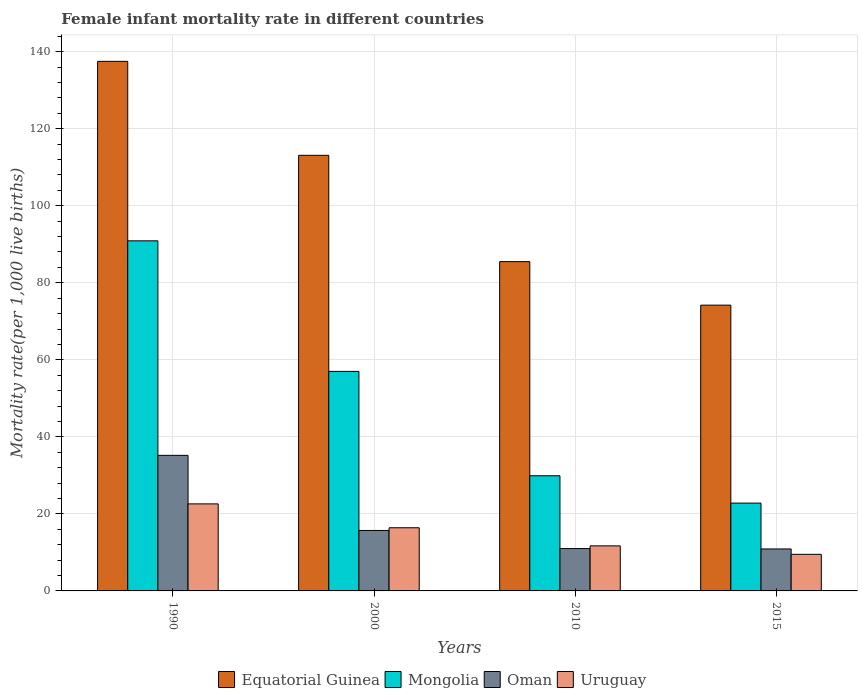Are the number of bars per tick equal to the number of legend labels?
Give a very brief answer. Yes. In how many cases, is the number of bars for a given year not equal to the number of legend labels?
Your answer should be compact. 0. What is the female infant mortality rate in Oman in 1990?
Make the answer very short. 35.2. Across all years, what is the maximum female infant mortality rate in Equatorial Guinea?
Provide a succinct answer. 137.5. Across all years, what is the minimum female infant mortality rate in Oman?
Make the answer very short. 10.9. In which year was the female infant mortality rate in Oman maximum?
Provide a short and direct response. 1990. In which year was the female infant mortality rate in Equatorial Guinea minimum?
Your answer should be compact. 2015. What is the total female infant mortality rate in Oman in the graph?
Ensure brevity in your answer.  72.8. What is the difference between the female infant mortality rate in Equatorial Guinea in 2010 and the female infant mortality rate in Oman in 2015?
Your answer should be very brief. 74.6. What is the average female infant mortality rate in Uruguay per year?
Your answer should be very brief. 15.05. In the year 2010, what is the difference between the female infant mortality rate in Equatorial Guinea and female infant mortality rate in Mongolia?
Your answer should be very brief. 55.6. In how many years, is the female infant mortality rate in Uruguay greater than 32?
Keep it short and to the point. 0. What is the ratio of the female infant mortality rate in Mongolia in 2000 to that in 2010?
Your response must be concise. 1.91. Is the female infant mortality rate in Equatorial Guinea in 2000 less than that in 2010?
Give a very brief answer. No. What is the difference between the highest and the second highest female infant mortality rate in Uruguay?
Offer a terse response. 6.2. What is the difference between the highest and the lowest female infant mortality rate in Uruguay?
Make the answer very short. 13.1. In how many years, is the female infant mortality rate in Equatorial Guinea greater than the average female infant mortality rate in Equatorial Guinea taken over all years?
Offer a very short reply. 2. Is the sum of the female infant mortality rate in Equatorial Guinea in 2000 and 2010 greater than the maximum female infant mortality rate in Uruguay across all years?
Your answer should be very brief. Yes. What does the 1st bar from the left in 1990 represents?
Your response must be concise. Equatorial Guinea. What does the 1st bar from the right in 2015 represents?
Offer a terse response. Uruguay. Is it the case that in every year, the sum of the female infant mortality rate in Oman and female infant mortality rate in Equatorial Guinea is greater than the female infant mortality rate in Uruguay?
Ensure brevity in your answer.  Yes. Are all the bars in the graph horizontal?
Offer a very short reply. No. How many years are there in the graph?
Provide a short and direct response. 4. How are the legend labels stacked?
Your answer should be very brief. Horizontal. What is the title of the graph?
Your response must be concise. Female infant mortality rate in different countries. Does "Virgin Islands" appear as one of the legend labels in the graph?
Provide a succinct answer. No. What is the label or title of the Y-axis?
Offer a very short reply. Mortality rate(per 1,0 live births). What is the Mortality rate(per 1,000 live births) in Equatorial Guinea in 1990?
Your answer should be very brief. 137.5. What is the Mortality rate(per 1,000 live births) of Mongolia in 1990?
Your answer should be very brief. 90.9. What is the Mortality rate(per 1,000 live births) of Oman in 1990?
Your response must be concise. 35.2. What is the Mortality rate(per 1,000 live births) of Uruguay in 1990?
Provide a succinct answer. 22.6. What is the Mortality rate(per 1,000 live births) of Equatorial Guinea in 2000?
Your answer should be compact. 113.1. What is the Mortality rate(per 1,000 live births) in Oman in 2000?
Offer a terse response. 15.7. What is the Mortality rate(per 1,000 live births) of Equatorial Guinea in 2010?
Your answer should be compact. 85.5. What is the Mortality rate(per 1,000 live births) of Mongolia in 2010?
Offer a terse response. 29.9. What is the Mortality rate(per 1,000 live births) in Uruguay in 2010?
Your answer should be very brief. 11.7. What is the Mortality rate(per 1,000 live births) of Equatorial Guinea in 2015?
Your response must be concise. 74.2. What is the Mortality rate(per 1,000 live births) of Mongolia in 2015?
Provide a succinct answer. 22.8. What is the Mortality rate(per 1,000 live births) of Oman in 2015?
Ensure brevity in your answer.  10.9. What is the Mortality rate(per 1,000 live births) in Uruguay in 2015?
Your answer should be compact. 9.5. Across all years, what is the maximum Mortality rate(per 1,000 live births) of Equatorial Guinea?
Offer a very short reply. 137.5. Across all years, what is the maximum Mortality rate(per 1,000 live births) in Mongolia?
Offer a terse response. 90.9. Across all years, what is the maximum Mortality rate(per 1,000 live births) of Oman?
Your answer should be compact. 35.2. Across all years, what is the maximum Mortality rate(per 1,000 live births) of Uruguay?
Provide a short and direct response. 22.6. Across all years, what is the minimum Mortality rate(per 1,000 live births) of Equatorial Guinea?
Provide a short and direct response. 74.2. Across all years, what is the minimum Mortality rate(per 1,000 live births) of Mongolia?
Offer a terse response. 22.8. What is the total Mortality rate(per 1,000 live births) in Equatorial Guinea in the graph?
Keep it short and to the point. 410.3. What is the total Mortality rate(per 1,000 live births) in Mongolia in the graph?
Provide a succinct answer. 200.6. What is the total Mortality rate(per 1,000 live births) of Oman in the graph?
Offer a very short reply. 72.8. What is the total Mortality rate(per 1,000 live births) of Uruguay in the graph?
Ensure brevity in your answer.  60.2. What is the difference between the Mortality rate(per 1,000 live births) of Equatorial Guinea in 1990 and that in 2000?
Provide a succinct answer. 24.4. What is the difference between the Mortality rate(per 1,000 live births) of Mongolia in 1990 and that in 2000?
Give a very brief answer. 33.9. What is the difference between the Mortality rate(per 1,000 live births) in Uruguay in 1990 and that in 2000?
Give a very brief answer. 6.2. What is the difference between the Mortality rate(per 1,000 live births) in Mongolia in 1990 and that in 2010?
Offer a terse response. 61. What is the difference between the Mortality rate(per 1,000 live births) in Oman in 1990 and that in 2010?
Provide a short and direct response. 24.2. What is the difference between the Mortality rate(per 1,000 live births) of Equatorial Guinea in 1990 and that in 2015?
Give a very brief answer. 63.3. What is the difference between the Mortality rate(per 1,000 live births) of Mongolia in 1990 and that in 2015?
Provide a short and direct response. 68.1. What is the difference between the Mortality rate(per 1,000 live births) in Oman in 1990 and that in 2015?
Your response must be concise. 24.3. What is the difference between the Mortality rate(per 1,000 live births) in Uruguay in 1990 and that in 2015?
Your answer should be very brief. 13.1. What is the difference between the Mortality rate(per 1,000 live births) of Equatorial Guinea in 2000 and that in 2010?
Your response must be concise. 27.6. What is the difference between the Mortality rate(per 1,000 live births) of Mongolia in 2000 and that in 2010?
Give a very brief answer. 27.1. What is the difference between the Mortality rate(per 1,000 live births) of Equatorial Guinea in 2000 and that in 2015?
Give a very brief answer. 38.9. What is the difference between the Mortality rate(per 1,000 live births) in Mongolia in 2000 and that in 2015?
Your response must be concise. 34.2. What is the difference between the Mortality rate(per 1,000 live births) of Oman in 2000 and that in 2015?
Keep it short and to the point. 4.8. What is the difference between the Mortality rate(per 1,000 live births) of Equatorial Guinea in 2010 and that in 2015?
Provide a succinct answer. 11.3. What is the difference between the Mortality rate(per 1,000 live births) in Oman in 2010 and that in 2015?
Make the answer very short. 0.1. What is the difference between the Mortality rate(per 1,000 live births) of Equatorial Guinea in 1990 and the Mortality rate(per 1,000 live births) of Mongolia in 2000?
Give a very brief answer. 80.5. What is the difference between the Mortality rate(per 1,000 live births) of Equatorial Guinea in 1990 and the Mortality rate(per 1,000 live births) of Oman in 2000?
Offer a very short reply. 121.8. What is the difference between the Mortality rate(per 1,000 live births) of Equatorial Guinea in 1990 and the Mortality rate(per 1,000 live births) of Uruguay in 2000?
Keep it short and to the point. 121.1. What is the difference between the Mortality rate(per 1,000 live births) in Mongolia in 1990 and the Mortality rate(per 1,000 live births) in Oman in 2000?
Make the answer very short. 75.2. What is the difference between the Mortality rate(per 1,000 live births) in Mongolia in 1990 and the Mortality rate(per 1,000 live births) in Uruguay in 2000?
Provide a succinct answer. 74.5. What is the difference between the Mortality rate(per 1,000 live births) in Equatorial Guinea in 1990 and the Mortality rate(per 1,000 live births) in Mongolia in 2010?
Keep it short and to the point. 107.6. What is the difference between the Mortality rate(per 1,000 live births) of Equatorial Guinea in 1990 and the Mortality rate(per 1,000 live births) of Oman in 2010?
Your response must be concise. 126.5. What is the difference between the Mortality rate(per 1,000 live births) in Equatorial Guinea in 1990 and the Mortality rate(per 1,000 live births) in Uruguay in 2010?
Ensure brevity in your answer.  125.8. What is the difference between the Mortality rate(per 1,000 live births) of Mongolia in 1990 and the Mortality rate(per 1,000 live births) of Oman in 2010?
Keep it short and to the point. 79.9. What is the difference between the Mortality rate(per 1,000 live births) in Mongolia in 1990 and the Mortality rate(per 1,000 live births) in Uruguay in 2010?
Provide a short and direct response. 79.2. What is the difference between the Mortality rate(per 1,000 live births) of Equatorial Guinea in 1990 and the Mortality rate(per 1,000 live births) of Mongolia in 2015?
Provide a succinct answer. 114.7. What is the difference between the Mortality rate(per 1,000 live births) of Equatorial Guinea in 1990 and the Mortality rate(per 1,000 live births) of Oman in 2015?
Offer a terse response. 126.6. What is the difference between the Mortality rate(per 1,000 live births) in Equatorial Guinea in 1990 and the Mortality rate(per 1,000 live births) in Uruguay in 2015?
Your answer should be very brief. 128. What is the difference between the Mortality rate(per 1,000 live births) of Mongolia in 1990 and the Mortality rate(per 1,000 live births) of Uruguay in 2015?
Your answer should be compact. 81.4. What is the difference between the Mortality rate(per 1,000 live births) in Oman in 1990 and the Mortality rate(per 1,000 live births) in Uruguay in 2015?
Your answer should be compact. 25.7. What is the difference between the Mortality rate(per 1,000 live births) in Equatorial Guinea in 2000 and the Mortality rate(per 1,000 live births) in Mongolia in 2010?
Your response must be concise. 83.2. What is the difference between the Mortality rate(per 1,000 live births) in Equatorial Guinea in 2000 and the Mortality rate(per 1,000 live births) in Oman in 2010?
Make the answer very short. 102.1. What is the difference between the Mortality rate(per 1,000 live births) in Equatorial Guinea in 2000 and the Mortality rate(per 1,000 live births) in Uruguay in 2010?
Provide a succinct answer. 101.4. What is the difference between the Mortality rate(per 1,000 live births) in Mongolia in 2000 and the Mortality rate(per 1,000 live births) in Oman in 2010?
Make the answer very short. 46. What is the difference between the Mortality rate(per 1,000 live births) in Mongolia in 2000 and the Mortality rate(per 1,000 live births) in Uruguay in 2010?
Give a very brief answer. 45.3. What is the difference between the Mortality rate(per 1,000 live births) in Oman in 2000 and the Mortality rate(per 1,000 live births) in Uruguay in 2010?
Provide a succinct answer. 4. What is the difference between the Mortality rate(per 1,000 live births) of Equatorial Guinea in 2000 and the Mortality rate(per 1,000 live births) of Mongolia in 2015?
Provide a short and direct response. 90.3. What is the difference between the Mortality rate(per 1,000 live births) of Equatorial Guinea in 2000 and the Mortality rate(per 1,000 live births) of Oman in 2015?
Keep it short and to the point. 102.2. What is the difference between the Mortality rate(per 1,000 live births) in Equatorial Guinea in 2000 and the Mortality rate(per 1,000 live births) in Uruguay in 2015?
Provide a succinct answer. 103.6. What is the difference between the Mortality rate(per 1,000 live births) of Mongolia in 2000 and the Mortality rate(per 1,000 live births) of Oman in 2015?
Your response must be concise. 46.1. What is the difference between the Mortality rate(per 1,000 live births) in Mongolia in 2000 and the Mortality rate(per 1,000 live births) in Uruguay in 2015?
Keep it short and to the point. 47.5. What is the difference between the Mortality rate(per 1,000 live births) in Equatorial Guinea in 2010 and the Mortality rate(per 1,000 live births) in Mongolia in 2015?
Offer a very short reply. 62.7. What is the difference between the Mortality rate(per 1,000 live births) in Equatorial Guinea in 2010 and the Mortality rate(per 1,000 live births) in Oman in 2015?
Provide a short and direct response. 74.6. What is the difference between the Mortality rate(per 1,000 live births) in Equatorial Guinea in 2010 and the Mortality rate(per 1,000 live births) in Uruguay in 2015?
Make the answer very short. 76. What is the difference between the Mortality rate(per 1,000 live births) in Mongolia in 2010 and the Mortality rate(per 1,000 live births) in Uruguay in 2015?
Offer a very short reply. 20.4. What is the average Mortality rate(per 1,000 live births) of Equatorial Guinea per year?
Ensure brevity in your answer.  102.58. What is the average Mortality rate(per 1,000 live births) of Mongolia per year?
Ensure brevity in your answer.  50.15. What is the average Mortality rate(per 1,000 live births) in Oman per year?
Your response must be concise. 18.2. What is the average Mortality rate(per 1,000 live births) in Uruguay per year?
Provide a succinct answer. 15.05. In the year 1990, what is the difference between the Mortality rate(per 1,000 live births) in Equatorial Guinea and Mortality rate(per 1,000 live births) in Mongolia?
Give a very brief answer. 46.6. In the year 1990, what is the difference between the Mortality rate(per 1,000 live births) of Equatorial Guinea and Mortality rate(per 1,000 live births) of Oman?
Provide a succinct answer. 102.3. In the year 1990, what is the difference between the Mortality rate(per 1,000 live births) of Equatorial Guinea and Mortality rate(per 1,000 live births) of Uruguay?
Your response must be concise. 114.9. In the year 1990, what is the difference between the Mortality rate(per 1,000 live births) in Mongolia and Mortality rate(per 1,000 live births) in Oman?
Ensure brevity in your answer.  55.7. In the year 1990, what is the difference between the Mortality rate(per 1,000 live births) of Mongolia and Mortality rate(per 1,000 live births) of Uruguay?
Provide a short and direct response. 68.3. In the year 2000, what is the difference between the Mortality rate(per 1,000 live births) of Equatorial Guinea and Mortality rate(per 1,000 live births) of Mongolia?
Give a very brief answer. 56.1. In the year 2000, what is the difference between the Mortality rate(per 1,000 live births) of Equatorial Guinea and Mortality rate(per 1,000 live births) of Oman?
Offer a very short reply. 97.4. In the year 2000, what is the difference between the Mortality rate(per 1,000 live births) in Equatorial Guinea and Mortality rate(per 1,000 live births) in Uruguay?
Your response must be concise. 96.7. In the year 2000, what is the difference between the Mortality rate(per 1,000 live births) in Mongolia and Mortality rate(per 1,000 live births) in Oman?
Keep it short and to the point. 41.3. In the year 2000, what is the difference between the Mortality rate(per 1,000 live births) of Mongolia and Mortality rate(per 1,000 live births) of Uruguay?
Your answer should be very brief. 40.6. In the year 2010, what is the difference between the Mortality rate(per 1,000 live births) in Equatorial Guinea and Mortality rate(per 1,000 live births) in Mongolia?
Your response must be concise. 55.6. In the year 2010, what is the difference between the Mortality rate(per 1,000 live births) in Equatorial Guinea and Mortality rate(per 1,000 live births) in Oman?
Offer a terse response. 74.5. In the year 2010, what is the difference between the Mortality rate(per 1,000 live births) in Equatorial Guinea and Mortality rate(per 1,000 live births) in Uruguay?
Keep it short and to the point. 73.8. In the year 2010, what is the difference between the Mortality rate(per 1,000 live births) in Mongolia and Mortality rate(per 1,000 live births) in Uruguay?
Provide a succinct answer. 18.2. In the year 2010, what is the difference between the Mortality rate(per 1,000 live births) in Oman and Mortality rate(per 1,000 live births) in Uruguay?
Ensure brevity in your answer.  -0.7. In the year 2015, what is the difference between the Mortality rate(per 1,000 live births) in Equatorial Guinea and Mortality rate(per 1,000 live births) in Mongolia?
Your response must be concise. 51.4. In the year 2015, what is the difference between the Mortality rate(per 1,000 live births) in Equatorial Guinea and Mortality rate(per 1,000 live births) in Oman?
Your response must be concise. 63.3. In the year 2015, what is the difference between the Mortality rate(per 1,000 live births) in Equatorial Guinea and Mortality rate(per 1,000 live births) in Uruguay?
Your answer should be very brief. 64.7. In the year 2015, what is the difference between the Mortality rate(per 1,000 live births) of Mongolia and Mortality rate(per 1,000 live births) of Uruguay?
Provide a succinct answer. 13.3. In the year 2015, what is the difference between the Mortality rate(per 1,000 live births) in Oman and Mortality rate(per 1,000 live births) in Uruguay?
Offer a very short reply. 1.4. What is the ratio of the Mortality rate(per 1,000 live births) in Equatorial Guinea in 1990 to that in 2000?
Offer a very short reply. 1.22. What is the ratio of the Mortality rate(per 1,000 live births) of Mongolia in 1990 to that in 2000?
Keep it short and to the point. 1.59. What is the ratio of the Mortality rate(per 1,000 live births) of Oman in 1990 to that in 2000?
Give a very brief answer. 2.24. What is the ratio of the Mortality rate(per 1,000 live births) of Uruguay in 1990 to that in 2000?
Make the answer very short. 1.38. What is the ratio of the Mortality rate(per 1,000 live births) in Equatorial Guinea in 1990 to that in 2010?
Your answer should be compact. 1.61. What is the ratio of the Mortality rate(per 1,000 live births) of Mongolia in 1990 to that in 2010?
Make the answer very short. 3.04. What is the ratio of the Mortality rate(per 1,000 live births) in Oman in 1990 to that in 2010?
Provide a short and direct response. 3.2. What is the ratio of the Mortality rate(per 1,000 live births) of Uruguay in 1990 to that in 2010?
Keep it short and to the point. 1.93. What is the ratio of the Mortality rate(per 1,000 live births) of Equatorial Guinea in 1990 to that in 2015?
Your response must be concise. 1.85. What is the ratio of the Mortality rate(per 1,000 live births) in Mongolia in 1990 to that in 2015?
Provide a short and direct response. 3.99. What is the ratio of the Mortality rate(per 1,000 live births) of Oman in 1990 to that in 2015?
Offer a terse response. 3.23. What is the ratio of the Mortality rate(per 1,000 live births) of Uruguay in 1990 to that in 2015?
Your answer should be compact. 2.38. What is the ratio of the Mortality rate(per 1,000 live births) in Equatorial Guinea in 2000 to that in 2010?
Your answer should be very brief. 1.32. What is the ratio of the Mortality rate(per 1,000 live births) of Mongolia in 2000 to that in 2010?
Keep it short and to the point. 1.91. What is the ratio of the Mortality rate(per 1,000 live births) in Oman in 2000 to that in 2010?
Your response must be concise. 1.43. What is the ratio of the Mortality rate(per 1,000 live births) of Uruguay in 2000 to that in 2010?
Provide a short and direct response. 1.4. What is the ratio of the Mortality rate(per 1,000 live births) of Equatorial Guinea in 2000 to that in 2015?
Offer a terse response. 1.52. What is the ratio of the Mortality rate(per 1,000 live births) of Oman in 2000 to that in 2015?
Ensure brevity in your answer.  1.44. What is the ratio of the Mortality rate(per 1,000 live births) of Uruguay in 2000 to that in 2015?
Provide a succinct answer. 1.73. What is the ratio of the Mortality rate(per 1,000 live births) in Equatorial Guinea in 2010 to that in 2015?
Your response must be concise. 1.15. What is the ratio of the Mortality rate(per 1,000 live births) in Mongolia in 2010 to that in 2015?
Provide a short and direct response. 1.31. What is the ratio of the Mortality rate(per 1,000 live births) of Oman in 2010 to that in 2015?
Make the answer very short. 1.01. What is the ratio of the Mortality rate(per 1,000 live births) of Uruguay in 2010 to that in 2015?
Give a very brief answer. 1.23. What is the difference between the highest and the second highest Mortality rate(per 1,000 live births) of Equatorial Guinea?
Give a very brief answer. 24.4. What is the difference between the highest and the second highest Mortality rate(per 1,000 live births) of Mongolia?
Your response must be concise. 33.9. What is the difference between the highest and the second highest Mortality rate(per 1,000 live births) in Oman?
Your response must be concise. 19.5. What is the difference between the highest and the lowest Mortality rate(per 1,000 live births) of Equatorial Guinea?
Your response must be concise. 63.3. What is the difference between the highest and the lowest Mortality rate(per 1,000 live births) in Mongolia?
Offer a very short reply. 68.1. What is the difference between the highest and the lowest Mortality rate(per 1,000 live births) of Oman?
Ensure brevity in your answer.  24.3. 